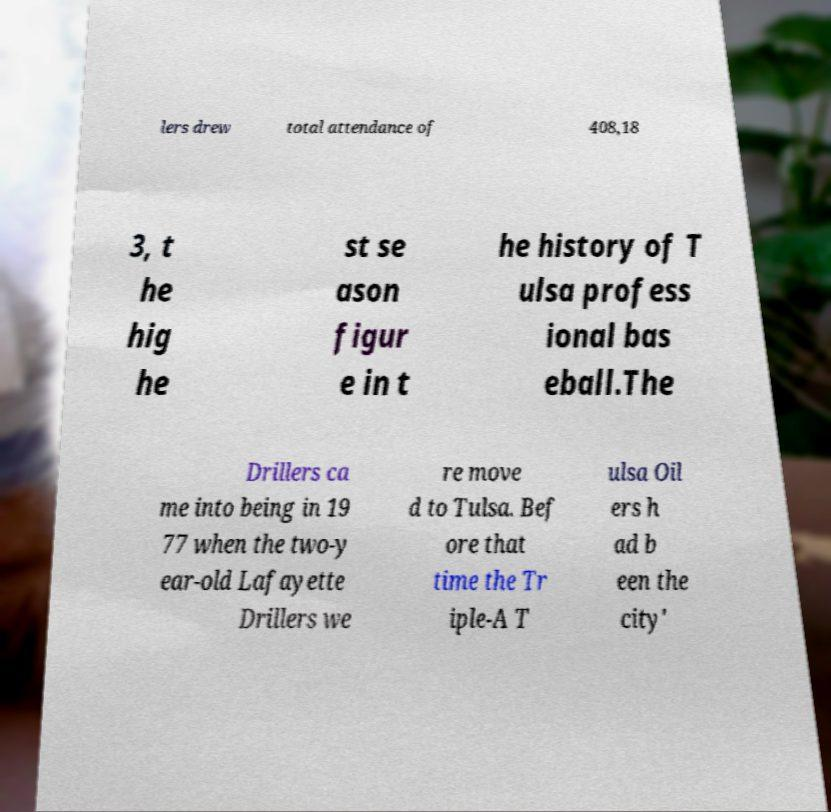Please identify and transcribe the text found in this image. lers drew total attendance of 408,18 3, t he hig he st se ason figur e in t he history of T ulsa profess ional bas eball.The Drillers ca me into being in 19 77 when the two-y ear-old Lafayette Drillers we re move d to Tulsa. Bef ore that time the Tr iple-A T ulsa Oil ers h ad b een the city' 